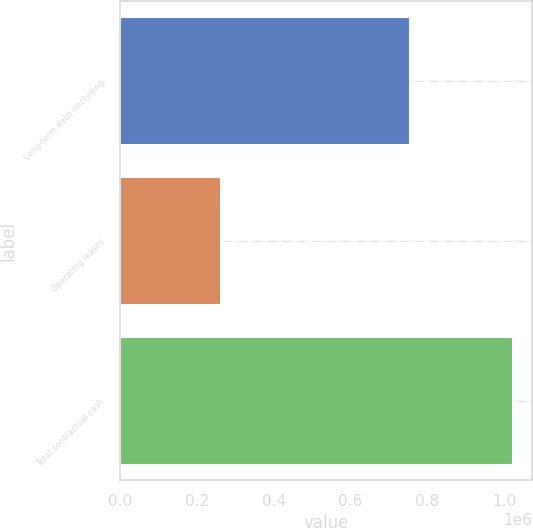Convert chart to OTSL. <chart><loc_0><loc_0><loc_500><loc_500><bar_chart><fcel>Long-term debt (including<fcel>Operating leases<fcel>Total contractual cash<nl><fcel>755156<fcel>262793<fcel>1.02229e+06<nl></chart> 